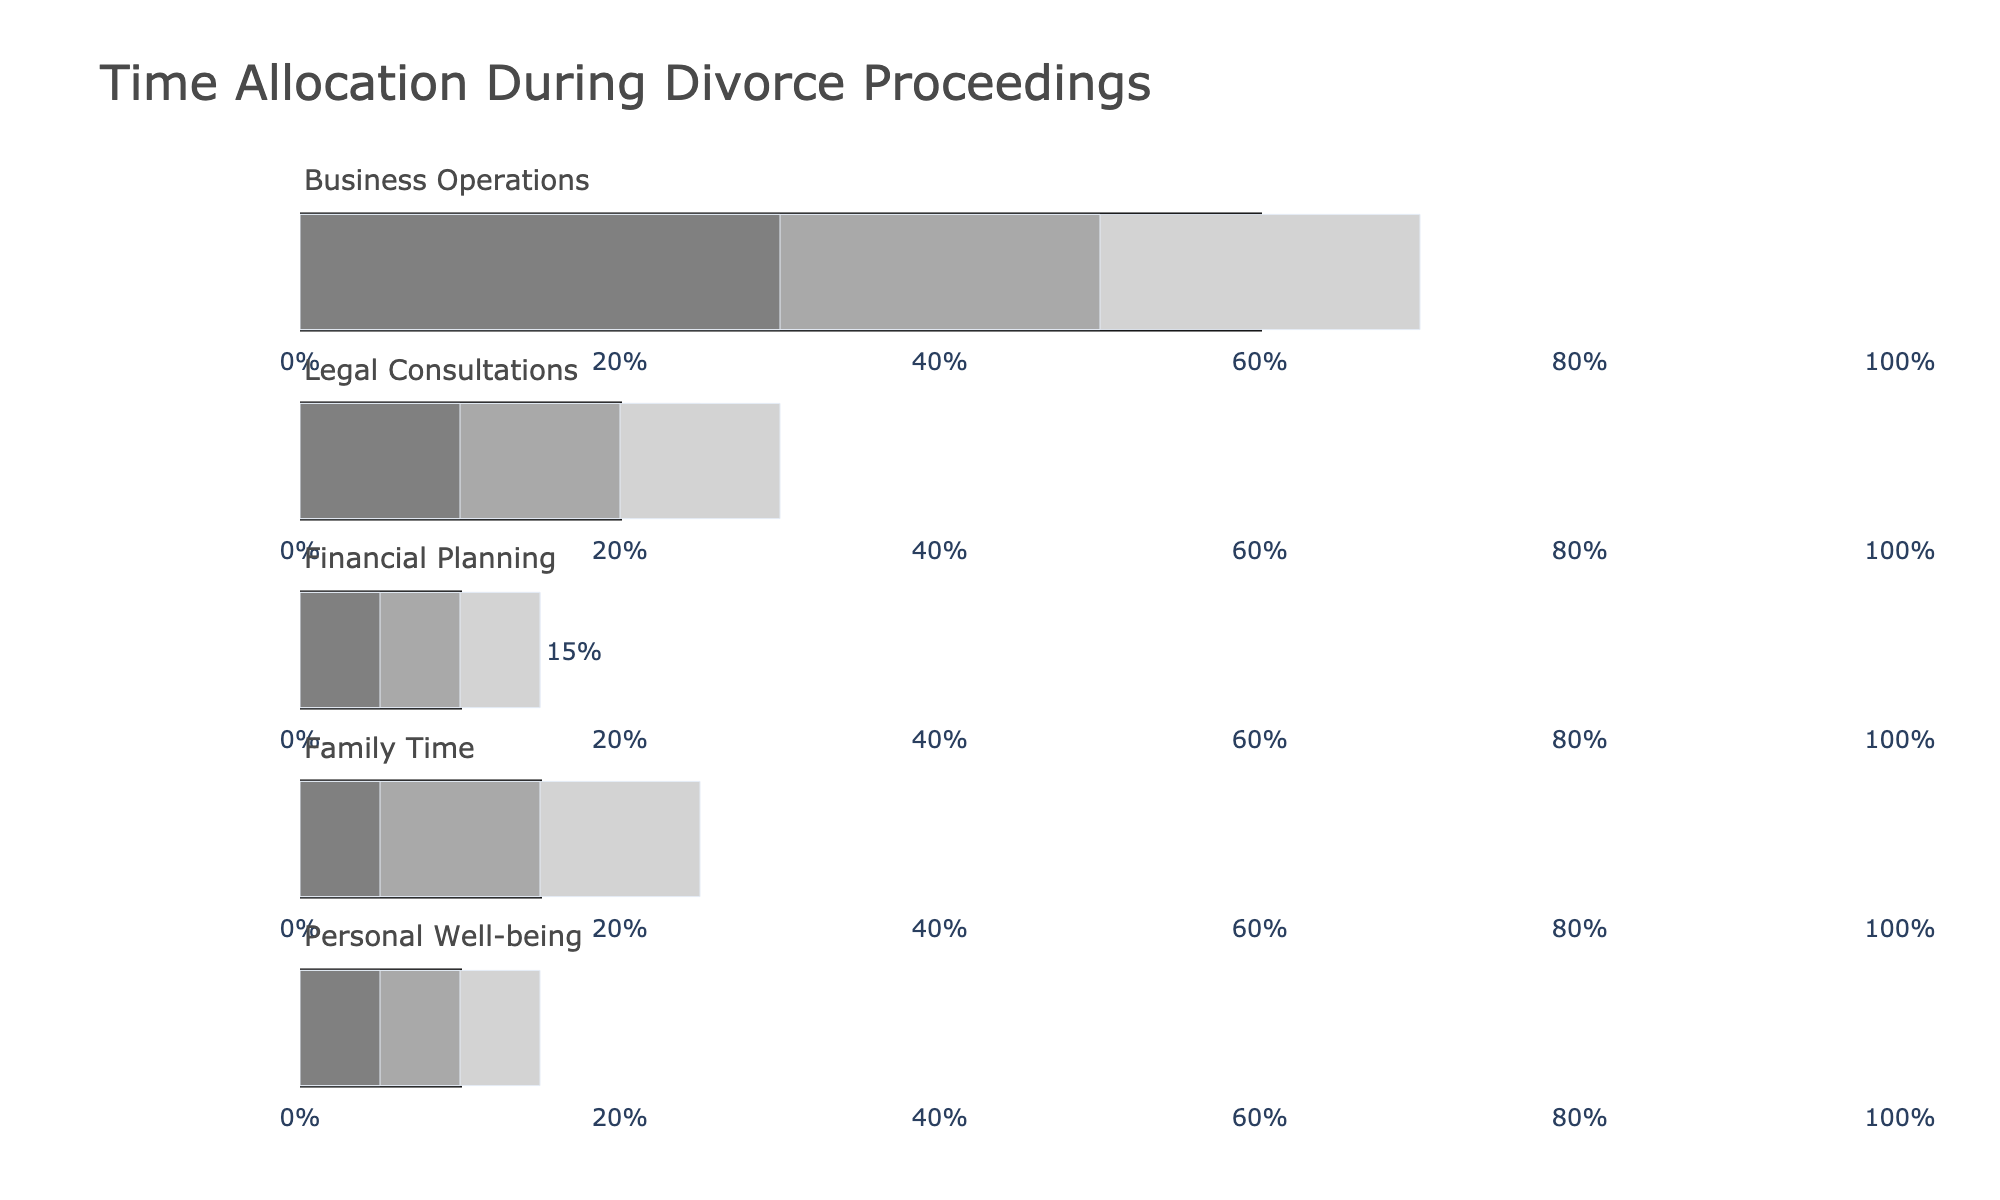What's the title of the figure? The title is displayed at the top center of the plot, which reads "Time Allocation During Divorce Proceedings".
Answer: Time Allocation During Divorce Proceedings Which category has the highest actual time allocation? To find the category with the highest actual allocation, look for the longest bar labeled "Actual" across all the rows. Business Operations has the longest bar with 45%.
Answer: Business Operations What is the target time allocation for Financial Planning? The target values are indicated by distinct bars. The target time allocation for Financial Planning is displayed as 10%.
Answer: 10% Compare the actual time allocation for Family Time and Personal Well-being. Which one is greater? Examine the heights of the bars labeled "Actual" for Family Time and Personal Well-being. Family Time has 10% while Personal Well-being has 5%. Therefore, Family Time is greater.
Answer: Family Time How much more time do you actually spend on Business Operations compared to the target? Subtract the target time allocation for Business Operations (60%) from the actual time allocation (45%). The difference is 45% - 60% = -15%. This signifies 15% less time than the target.
Answer: -15% What's the combined target time allocation for Legal Consultations and Family Time? Add the target values for Legal Consultations (20%) and Family Time (15%). The sum is 20% + 15% = 35%.
Answer: 35% Which category shows an actual time allocation equal to its least desirable range end-point? Find the category where the actual time allocation matches the range labeled "Range1". Personal Well-being has an actual time allocation of 5% which matches its Range1 value.
Answer: Personal Well-being How does the actual time allocation for Legal Consultations compare to its target? Compare the actual time allocation (25%) with the target (20%) for Legal Consultations. The actual allocation is 5% more than the target.
Answer: 5% more Which category has the smallest gap between actual and target time allocations? Calculate the absolute differences between actual and target values for each category. Financial Planning has the smallest gap (15% actual - 10% target = 5% gap).
Answer: Financial Planning What's the average of the actual time allocations across all categories? Sum the actual time allocations (45% + 25% + 15% + 10% + 5%) and divide by the number of categories (5). The calculation is (45 + 25 + 15 + 10 + 5) / 5 = 20%.
Answer: 20% 